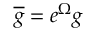<formula> <loc_0><loc_0><loc_500><loc_500>\overline { g } = e ^ { \Omega } g</formula> 